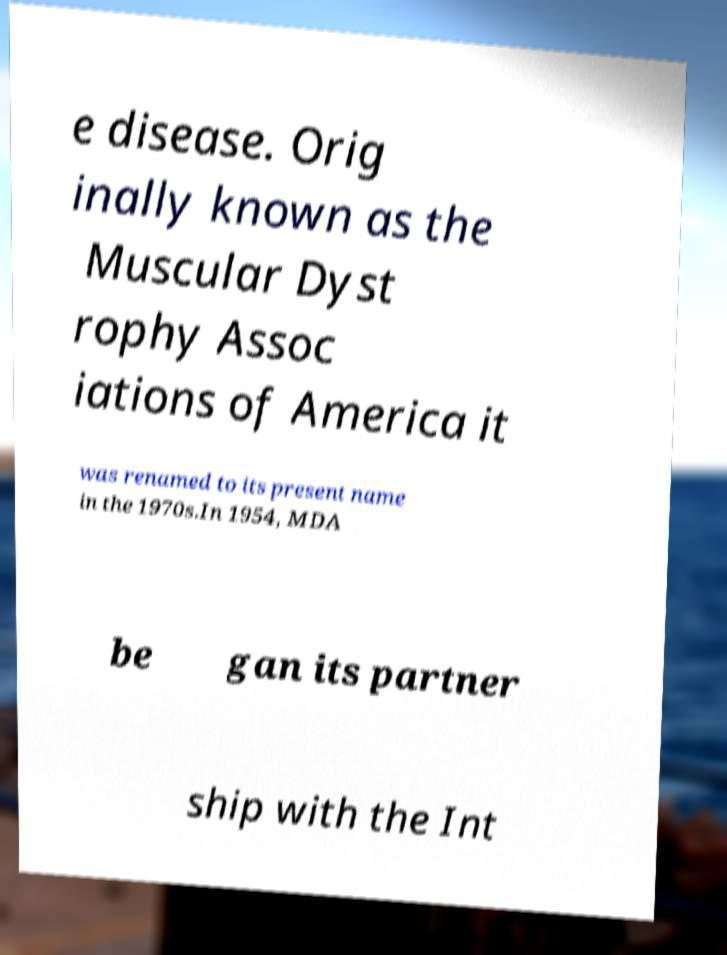Please read and relay the text visible in this image. What does it say? e disease. Orig inally known as the Muscular Dyst rophy Assoc iations of America it was renamed to its present name in the 1970s.In 1954, MDA be gan its partner ship with the Int 